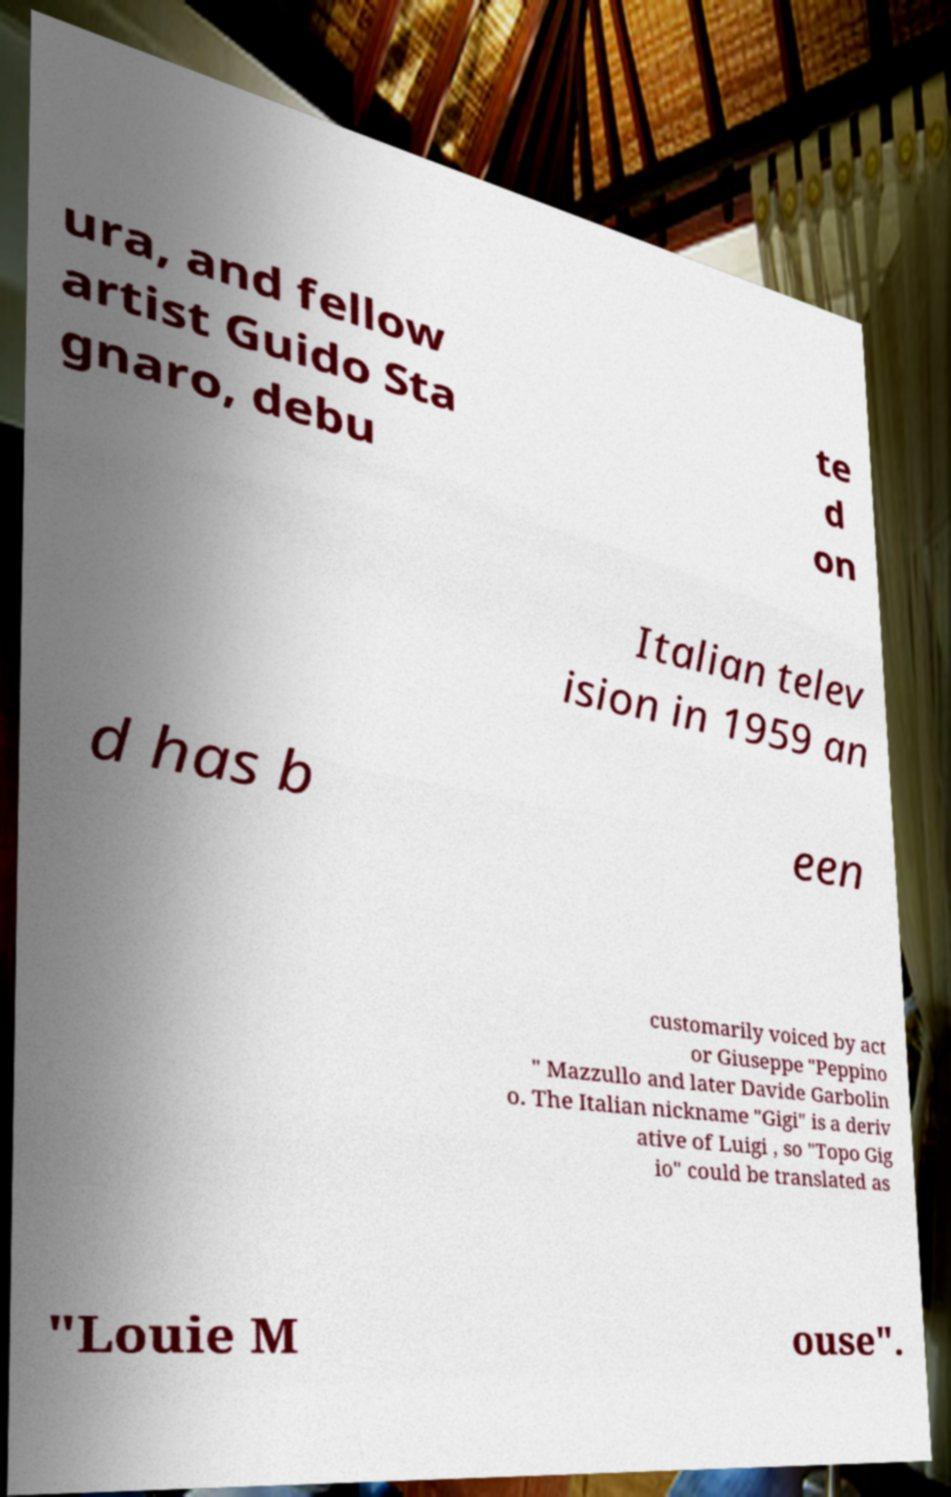Can you accurately transcribe the text from the provided image for me? ura, and fellow artist Guido Sta gnaro, debu te d on Italian telev ision in 1959 an d has b een customarily voiced by act or Giuseppe "Peppino " Mazzullo and later Davide Garbolin o. The Italian nickname "Gigi" is a deriv ative of Luigi , so "Topo Gig io" could be translated as "Louie M ouse". 